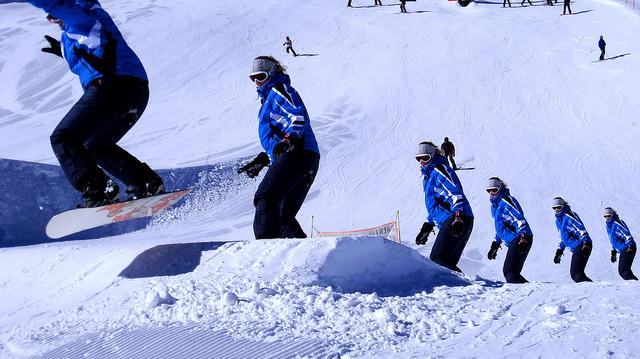What technique was used to manipulate this photo? Please explain your reasoning. time lapse. The same person is shown in different parts of the photograph which shows the pictures were taken at different times. 